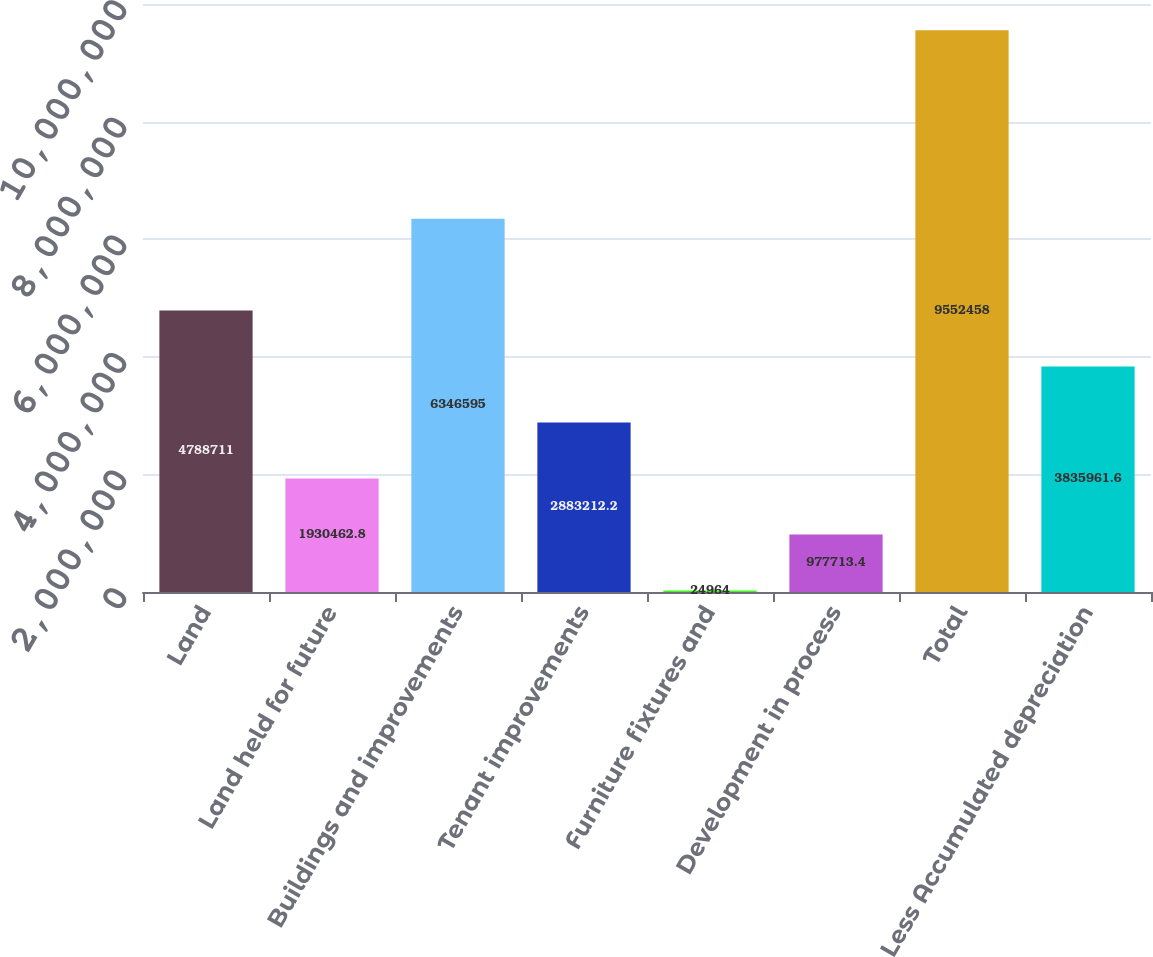Convert chart. <chart><loc_0><loc_0><loc_500><loc_500><bar_chart><fcel>Land<fcel>Land held for future<fcel>Buildings and improvements<fcel>Tenant improvements<fcel>Furniture fixtures and<fcel>Development in process<fcel>Total<fcel>Less Accumulated depreciation<nl><fcel>4.78871e+06<fcel>1.93046e+06<fcel>6.3466e+06<fcel>2.88321e+06<fcel>24964<fcel>977713<fcel>9.55246e+06<fcel>3.83596e+06<nl></chart> 